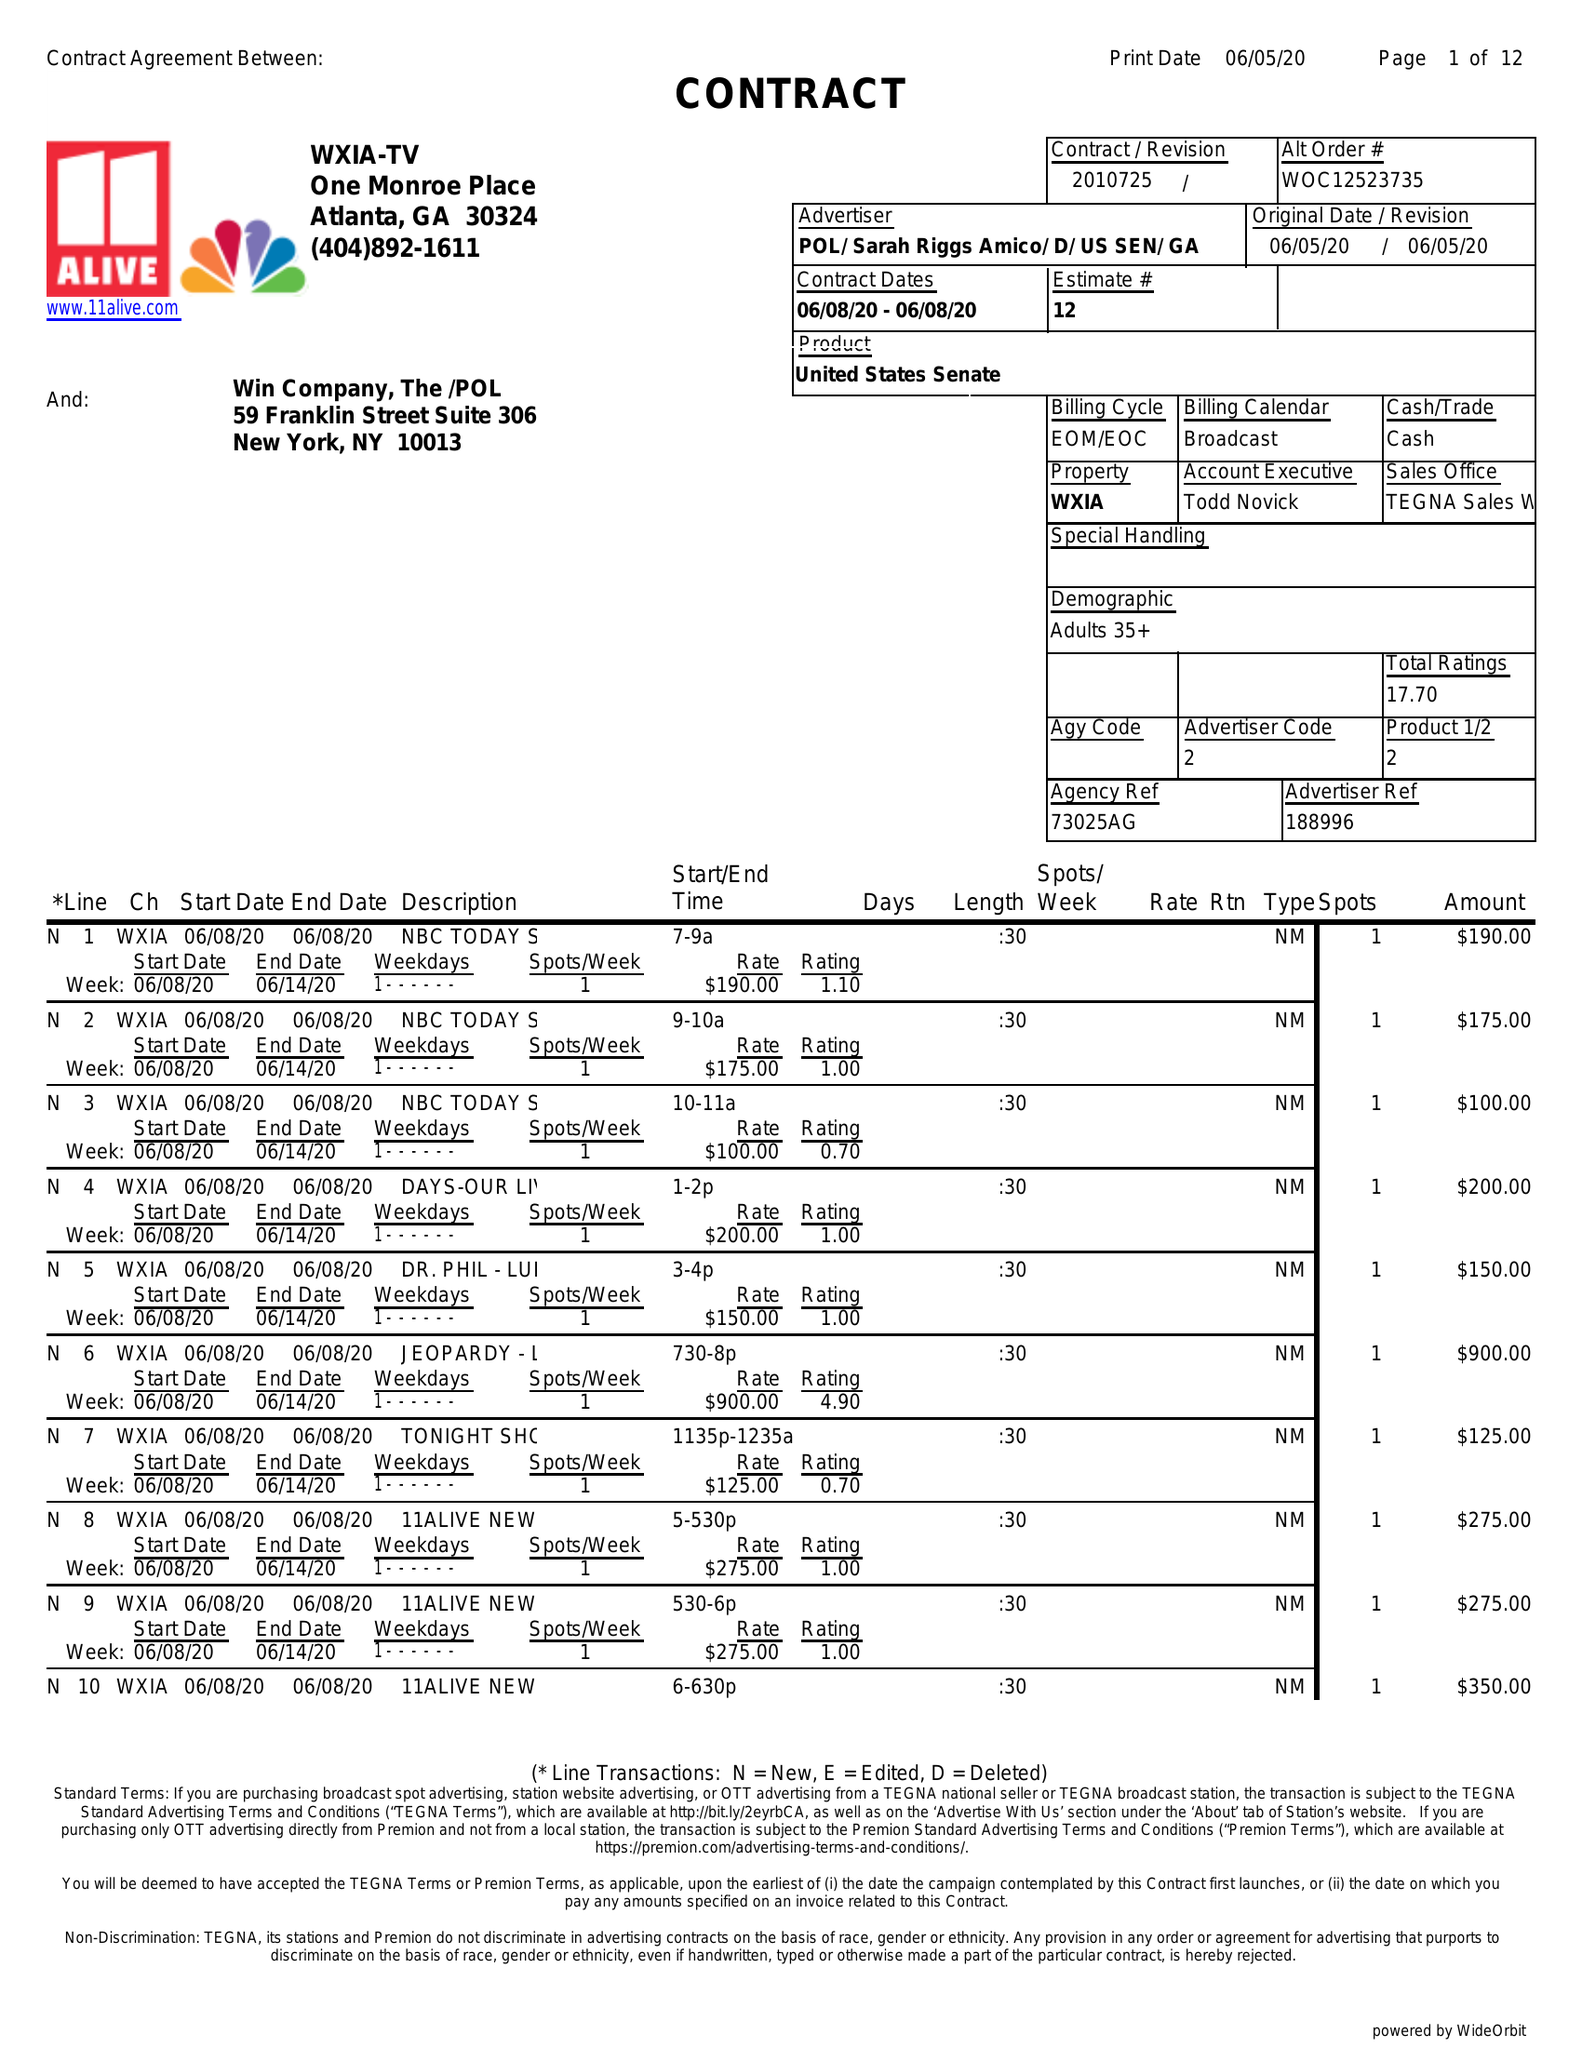What is the value for the contract_num?
Answer the question using a single word or phrase. 2010725 